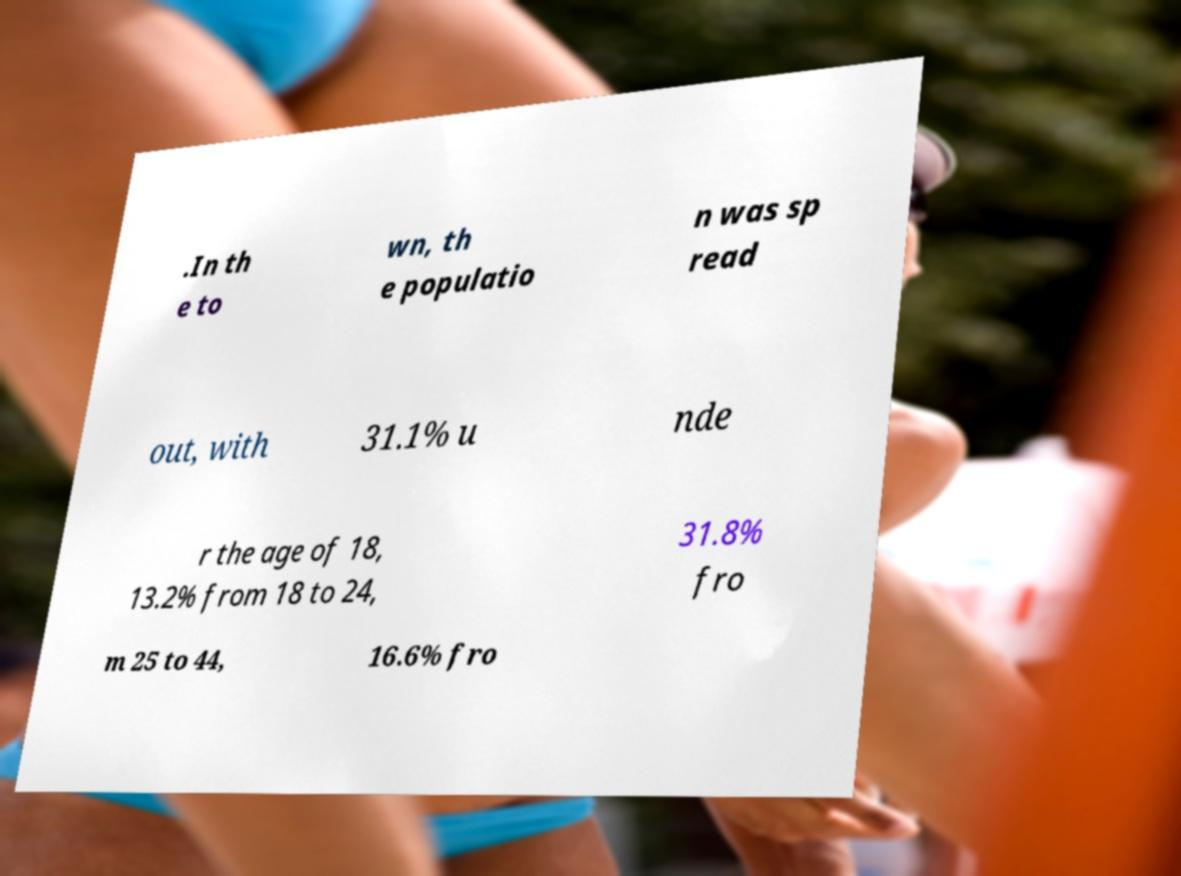Could you assist in decoding the text presented in this image and type it out clearly? .In th e to wn, th e populatio n was sp read out, with 31.1% u nde r the age of 18, 13.2% from 18 to 24, 31.8% fro m 25 to 44, 16.6% fro 